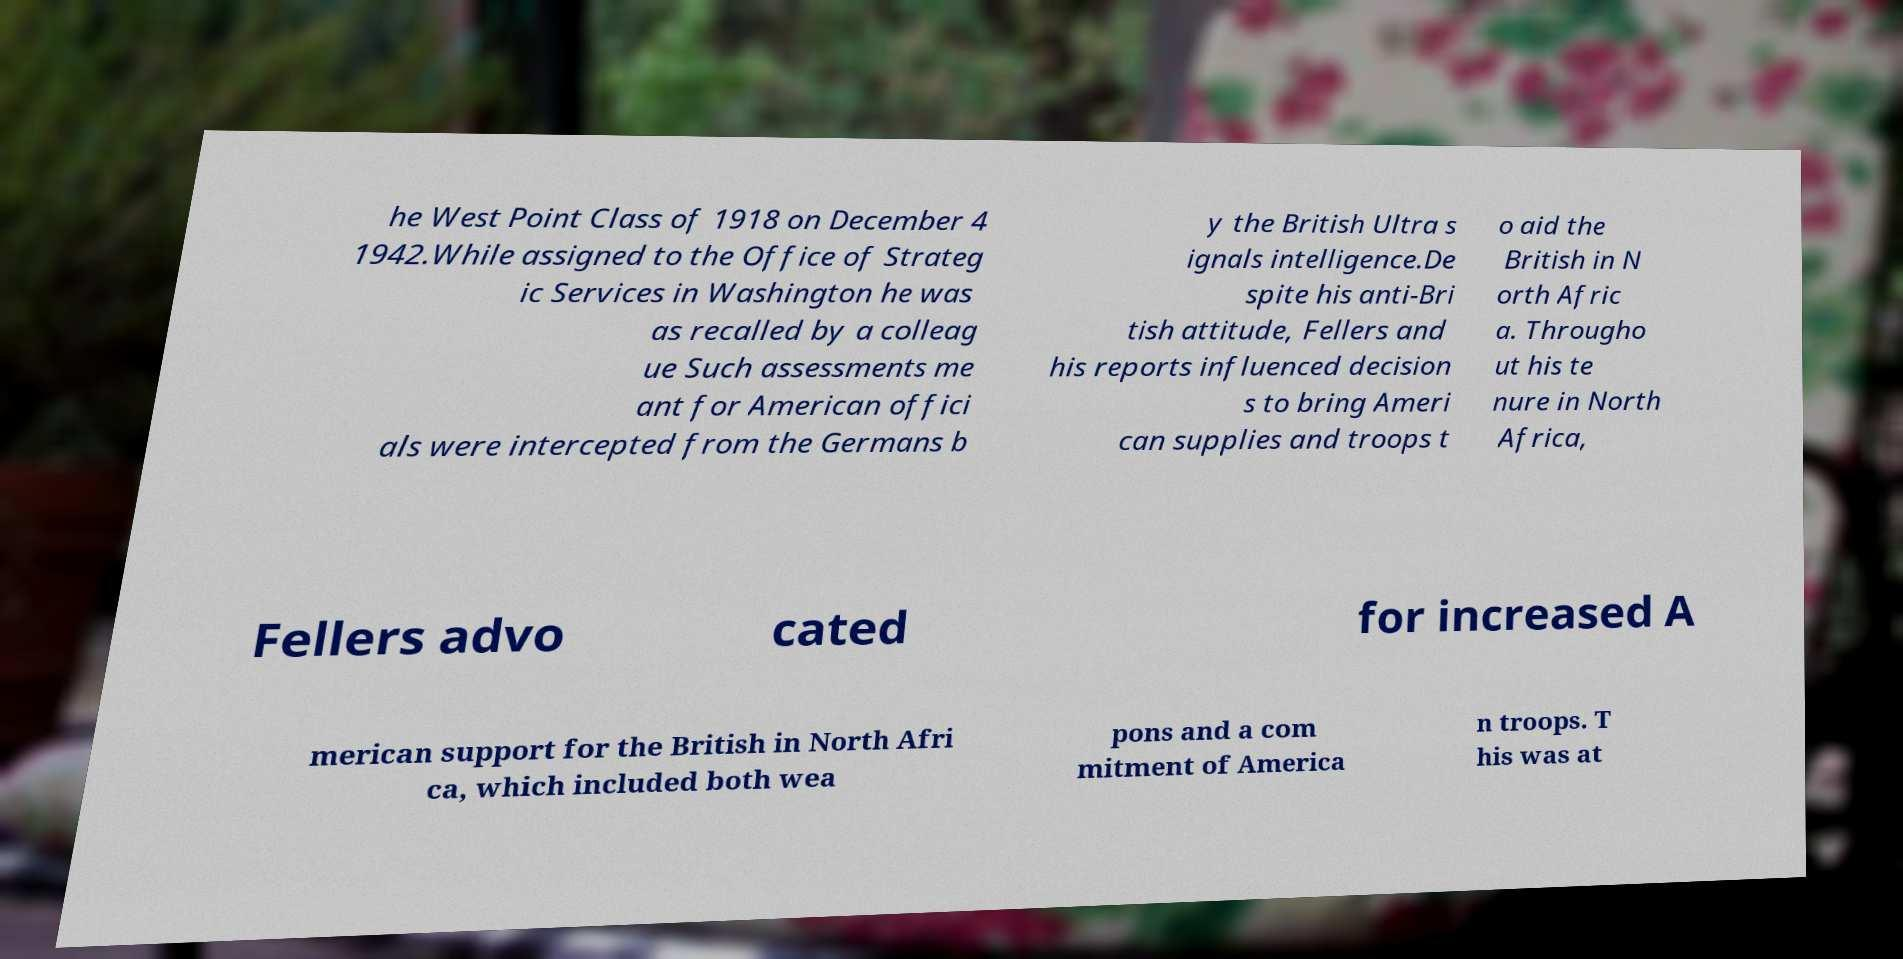Could you extract and type out the text from this image? he West Point Class of 1918 on December 4 1942.While assigned to the Office of Strateg ic Services in Washington he was as recalled by a colleag ue Such assessments me ant for American offici als were intercepted from the Germans b y the British Ultra s ignals intelligence.De spite his anti-Bri tish attitude, Fellers and his reports influenced decision s to bring Ameri can supplies and troops t o aid the British in N orth Afric a. Througho ut his te nure in North Africa, Fellers advo cated for increased A merican support for the British in North Afri ca, which included both wea pons and a com mitment of America n troops. T his was at 